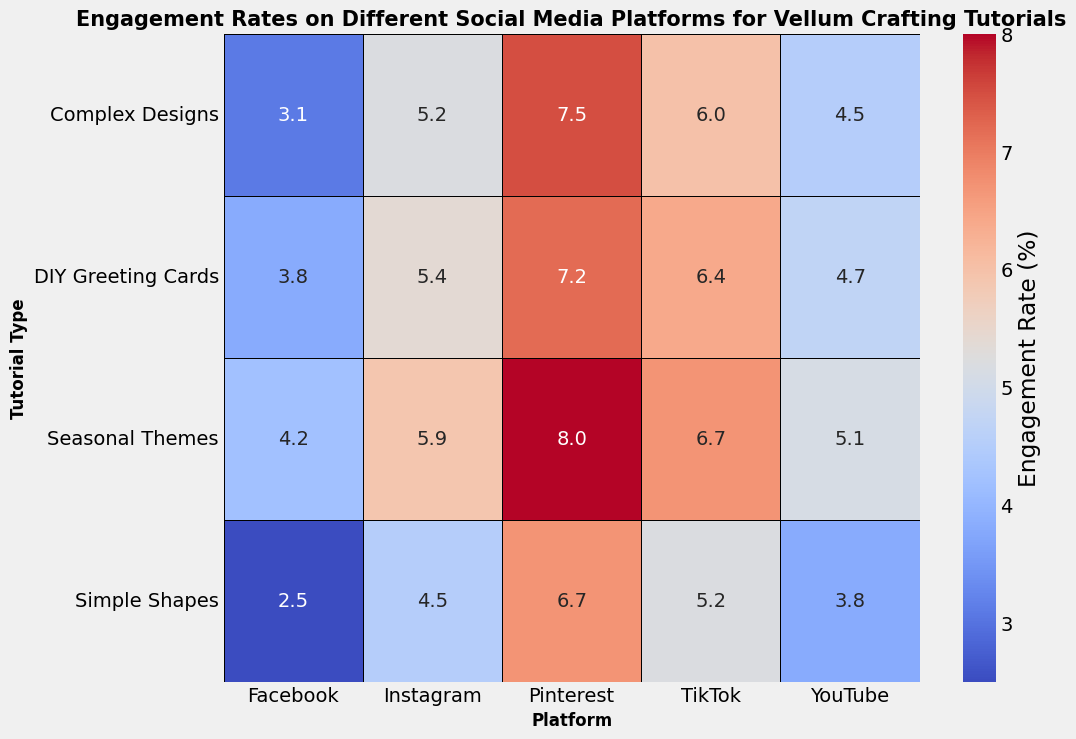What is the platform with the highest overall engagement rate for DIY Greeting Cards tutorials? First, look at the Engagement Rate for DIY Greeting Cards across all platforms. Facebook has 3.8%, Instagram has 5.4%, Pinterest has 7.2%, YouTube has 4.7%, and TikTok has 6.4%. Pinterest has the highest rate.
Answer: Pinterest Which tutorial type has the lowest engagement rate on Instagram? Look at the Engagement Rates for every tutorial type on Instagram and compare them. Simple Shapes has 4.5%, Complex Designs has 5.2%, Seasonal Themes has 5.9%, and DIY Greeting Cards has 5.4%. Simple Shapes has the lowest rate.
Answer: Simple Shapes What is the difference in engagement rates between Seasonal Themes and Simple Shapes on Pinterest? Look at the Engagement Rates on Pinterest for both Seasonal Themes and Simple Shapes. Seasonal Themes have an 8.0% engagement rate and Simple Shapes have 6.7%. Calculate the difference: 8.0 - 6.7 = 1.3%.
Answer: 1.3% Which two platforms have the most similar engagement rates for Complex Designs tutorials? Look at the Engagement Rates for Complex Designs across all platforms. Facebook has 3.1%, Instagram has 5.2%, Pinterest has 7.5%, YouTube has 4.5%, and TikTok has 6.0%. The closest are YouTube (4.5%) and Instagram (5.2%), with a difference of 5.2 - 4.5 = 0.7.
Answer: Instagram and YouTube What color represents the highest engagement rates on the heatmap? The colors in the heatmap range from cooler to warmer, where warmer colors represent higher engagement rates. The highest engagement rates would likely be found among the darkest red-colored cells.
Answer: Red Calculate the average engagement rate for Complex Designs tutorials across all platforms. Add all the engagement rates for Complex Designs: Facebook (3.1), Instagram (5.2), Pinterest (7.5), YouTube (4.5), and TikTok (6.0). The sum is 3.1 + 5.2 + 7.5 + 4.5 + 6.0 = 26.3. Divide by the number of platforms (5): 26.3 / 5 = 5.26%.
Answer: 5.26% Compare the engagement rates for Simple Shapes tutorials between Instagram and TikTok; which is higher and by how much? Look at the Engagement Rates for Simple Shapes on Instagram (4.5%) and TikTok (5.2%). Calculate the difference: 5.2 - 4.5 = 0.7%. TikTok has a higher rate.
Answer: TikTok by 0.7% Which tutorial type on YouTube has the closest engagement rate to the average rate across all platforms for that tutorial type? Calculate the average for each tutorial type across all platforms. For example, the average for Simple Shapes is (2.5+4.5+6.7+3.8+5.2)/5 = 4.54%. Then, compare YouTube's rates. DIY Greeting Cards on YouTube (4.7%) is closest to its average (5.1%).
Answer: DIY Greeting Cards What is the total engagement rate across all platforms for Seasonal Themes tutorials? Add the Engagement Rates for Seasonal Themes across all platforms: Facebook (4.2), Instagram (5.9), Pinterest (8.0), YouTube (5.1), and TikTok (6.7). The sum is 4.2 + 5.9 + 8.0 + 5.1 + 6.7 = 29.9%.
Answer: 29.9% Which platform shows the most variance in engagement rates across all tutorials? Calculate the range (max-min) of engagement rates for each platform. The variance would be between the highest and lowest numbers for each platform. Pinterest ranges from 6.7 to 8.0 (8.0-6.7=1.3), TikTok from 5.2 to 6.7 (6.7-5.2=1.5), Instagram from 4.5 to 5.9 (5.9-4.5=1.4), YouTube from 3.8 to 5.1 (5.1-3.8=1.3), and Facebook from 2.5 to 4.2 (4.2-2.5=1.7). Facebook shows the most variance (1.7).
Answer: Facebook 